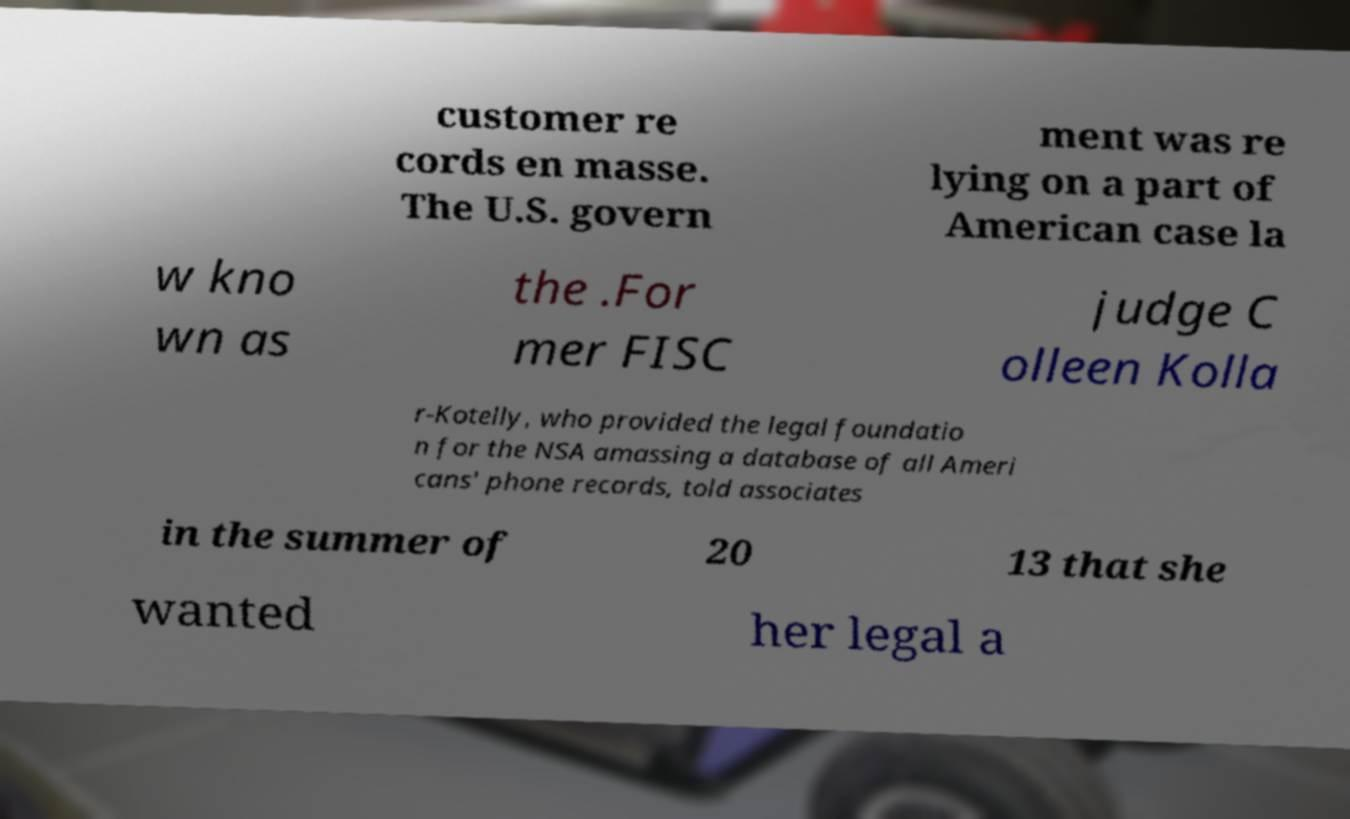Could you extract and type out the text from this image? customer re cords en masse. The U.S. govern ment was re lying on a part of American case la w kno wn as the .For mer FISC judge C olleen Kolla r-Kotelly, who provided the legal foundatio n for the NSA amassing a database of all Ameri cans' phone records, told associates in the summer of 20 13 that she wanted her legal a 